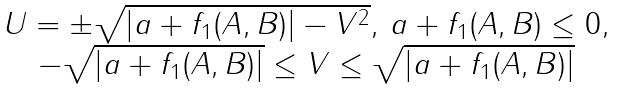Convert formula to latex. <formula><loc_0><loc_0><loc_500><loc_500>\begin{matrix} U = \pm \sqrt { | a + f _ { 1 } ( A , B ) | - V ^ { 2 } } , \, a + f _ { 1 } ( A , B ) \leq 0 , \\ - \sqrt { | a + f _ { 1 } ( A , B ) | } \leq V \leq \sqrt { | a + f _ { 1 } ( A , B ) | } \end{matrix}</formula> 